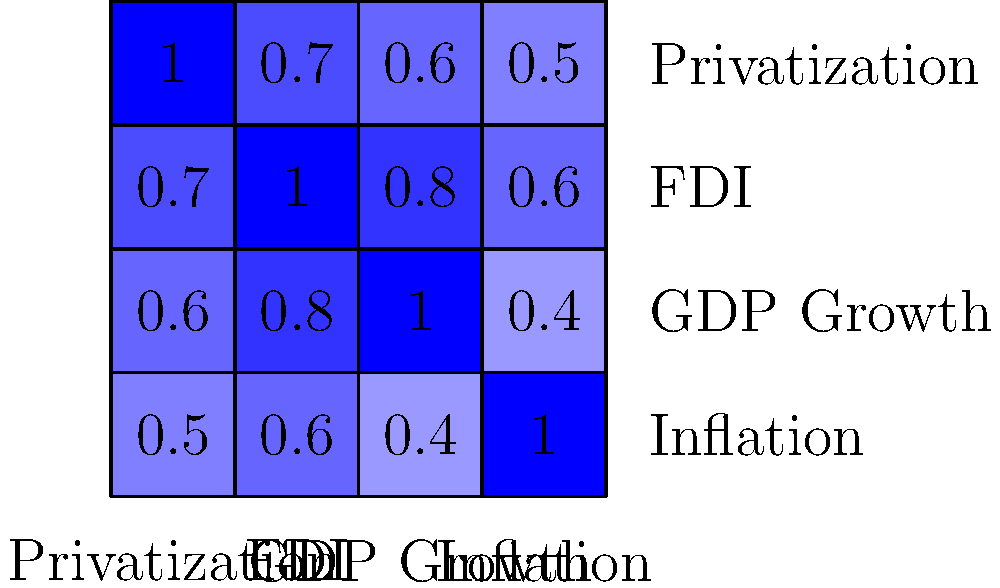Based on the correlation matrix heatmap provided, which economic indicator shows the strongest positive correlation with privatization rates in post-Soviet economies transitioning to market-oriented policies? To answer this question, we need to analyze the correlation coefficients between privatization and other economic indicators in the heatmap. Let's examine the process step-by-step:

1. Identify the row or column for privatization:
   The first row/column represents privatization.

2. Analyze the correlation coefficients:
   - Privatization vs. FDI: 0.7
   - Privatization vs. GDP Growth: 0.6
   - Privatization vs. Inflation: 0.5

3. Compare the correlation coefficients:
   The highest positive correlation coefficient with privatization is 0.7, which corresponds to FDI (Foreign Direct Investment).

4. Interpret the result:
   A correlation coefficient of 0.7 indicates a strong positive relationship between privatization rates and FDI. This suggests that as privatization rates increase in post-Soviet economies, there is a tendency for FDI to increase as well, or vice versa.

5. Consider the economic implications:
   This strong positive correlation aligns with economic theory, as privatization often attracts foreign investors by creating opportunities for investment in newly privatized companies and sectors.

Therefore, based on the correlation matrix heatmap, FDI shows the strongest positive correlation with privatization rates in post-Soviet economies transitioning to market-oriented policies.
Answer: Foreign Direct Investment (FDI) 